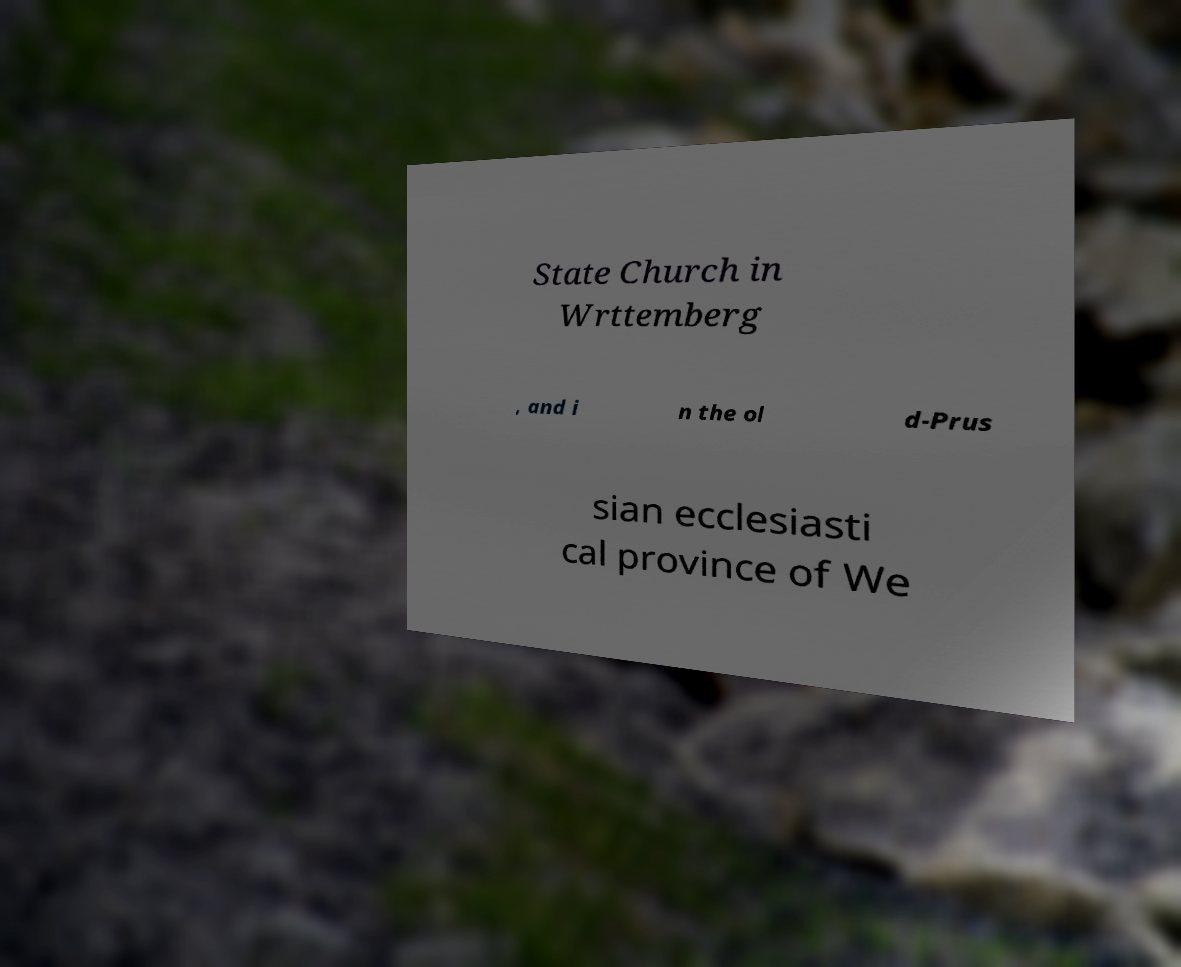What messages or text are displayed in this image? I need them in a readable, typed format. State Church in Wrttemberg , and i n the ol d-Prus sian ecclesiasti cal province of We 